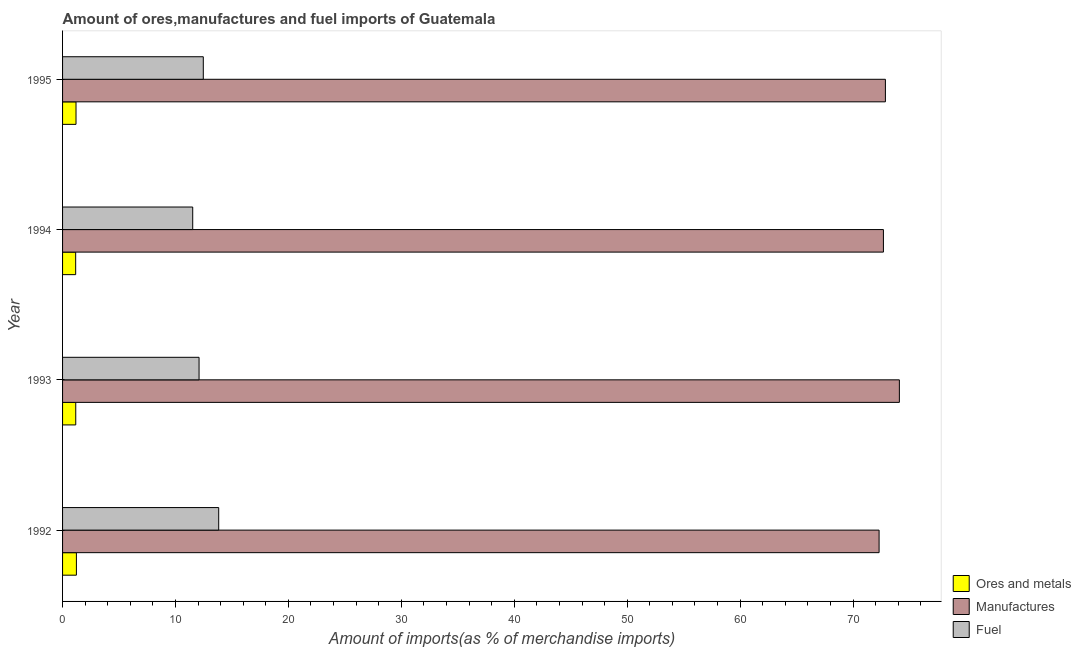How many different coloured bars are there?
Your answer should be compact. 3. How many groups of bars are there?
Provide a short and direct response. 4. Are the number of bars per tick equal to the number of legend labels?
Your response must be concise. Yes. How many bars are there on the 2nd tick from the top?
Make the answer very short. 3. What is the label of the 4th group of bars from the top?
Offer a very short reply. 1992. What is the percentage of manufactures imports in 1995?
Offer a very short reply. 72.87. Across all years, what is the maximum percentage of fuel imports?
Make the answer very short. 13.83. Across all years, what is the minimum percentage of ores and metals imports?
Provide a succinct answer. 1.16. In which year was the percentage of fuel imports minimum?
Offer a terse response. 1994. What is the total percentage of manufactures imports in the graph?
Your response must be concise. 291.98. What is the difference between the percentage of fuel imports in 1992 and that in 1993?
Your answer should be very brief. 1.74. What is the difference between the percentage of ores and metals imports in 1995 and the percentage of manufactures imports in 1993?
Make the answer very short. -72.92. What is the average percentage of fuel imports per year?
Make the answer very short. 12.48. In the year 1994, what is the difference between the percentage of ores and metals imports and percentage of fuel imports?
Give a very brief answer. -10.37. In how many years, is the percentage of manufactures imports greater than 68 %?
Provide a succinct answer. 4. What is the difference between the highest and the second highest percentage of manufactures imports?
Offer a very short reply. 1.24. What is the difference between the highest and the lowest percentage of ores and metals imports?
Offer a terse response. 0.06. In how many years, is the percentage of ores and metals imports greater than the average percentage of ores and metals imports taken over all years?
Keep it short and to the point. 2. Is the sum of the percentage of ores and metals imports in 1992 and 1993 greater than the maximum percentage of fuel imports across all years?
Give a very brief answer. No. What does the 3rd bar from the top in 1993 represents?
Your answer should be compact. Ores and metals. What does the 1st bar from the bottom in 1993 represents?
Give a very brief answer. Ores and metals. How many bars are there?
Offer a terse response. 12. How many years are there in the graph?
Give a very brief answer. 4. What is the difference between two consecutive major ticks on the X-axis?
Your answer should be very brief. 10. Are the values on the major ticks of X-axis written in scientific E-notation?
Provide a succinct answer. No. Does the graph contain grids?
Your answer should be compact. No. How many legend labels are there?
Your response must be concise. 3. How are the legend labels stacked?
Give a very brief answer. Vertical. What is the title of the graph?
Your answer should be compact. Amount of ores,manufactures and fuel imports of Guatemala. Does "Unpaid family workers" appear as one of the legend labels in the graph?
Provide a succinct answer. No. What is the label or title of the X-axis?
Offer a terse response. Amount of imports(as % of merchandise imports). What is the label or title of the Y-axis?
Keep it short and to the point. Year. What is the Amount of imports(as % of merchandise imports) of Ores and metals in 1992?
Keep it short and to the point. 1.23. What is the Amount of imports(as % of merchandise imports) in Manufactures in 1992?
Offer a terse response. 72.31. What is the Amount of imports(as % of merchandise imports) of Fuel in 1992?
Make the answer very short. 13.83. What is the Amount of imports(as % of merchandise imports) of Ores and metals in 1993?
Offer a terse response. 1.17. What is the Amount of imports(as % of merchandise imports) of Manufactures in 1993?
Offer a terse response. 74.11. What is the Amount of imports(as % of merchandise imports) of Fuel in 1993?
Offer a terse response. 12.09. What is the Amount of imports(as % of merchandise imports) in Ores and metals in 1994?
Ensure brevity in your answer.  1.16. What is the Amount of imports(as % of merchandise imports) in Manufactures in 1994?
Provide a succinct answer. 72.69. What is the Amount of imports(as % of merchandise imports) of Fuel in 1994?
Your answer should be very brief. 11.53. What is the Amount of imports(as % of merchandise imports) of Ores and metals in 1995?
Your answer should be compact. 1.19. What is the Amount of imports(as % of merchandise imports) in Manufactures in 1995?
Ensure brevity in your answer.  72.87. What is the Amount of imports(as % of merchandise imports) of Fuel in 1995?
Your answer should be compact. 12.46. Across all years, what is the maximum Amount of imports(as % of merchandise imports) of Ores and metals?
Your answer should be very brief. 1.23. Across all years, what is the maximum Amount of imports(as % of merchandise imports) of Manufactures?
Your response must be concise. 74.11. Across all years, what is the maximum Amount of imports(as % of merchandise imports) of Fuel?
Your response must be concise. 13.83. Across all years, what is the minimum Amount of imports(as % of merchandise imports) in Ores and metals?
Your answer should be very brief. 1.16. Across all years, what is the minimum Amount of imports(as % of merchandise imports) of Manufactures?
Your response must be concise. 72.31. Across all years, what is the minimum Amount of imports(as % of merchandise imports) in Fuel?
Provide a succinct answer. 11.53. What is the total Amount of imports(as % of merchandise imports) of Ores and metals in the graph?
Your answer should be compact. 4.74. What is the total Amount of imports(as % of merchandise imports) in Manufactures in the graph?
Offer a very short reply. 291.98. What is the total Amount of imports(as % of merchandise imports) of Fuel in the graph?
Provide a short and direct response. 49.9. What is the difference between the Amount of imports(as % of merchandise imports) in Ores and metals in 1992 and that in 1993?
Make the answer very short. 0.06. What is the difference between the Amount of imports(as % of merchandise imports) in Manufactures in 1992 and that in 1993?
Offer a terse response. -1.8. What is the difference between the Amount of imports(as % of merchandise imports) of Fuel in 1992 and that in 1993?
Offer a terse response. 1.74. What is the difference between the Amount of imports(as % of merchandise imports) of Ores and metals in 1992 and that in 1994?
Give a very brief answer. 0.06. What is the difference between the Amount of imports(as % of merchandise imports) in Manufactures in 1992 and that in 1994?
Your response must be concise. -0.38. What is the difference between the Amount of imports(as % of merchandise imports) in Fuel in 1992 and that in 1994?
Your answer should be compact. 2.3. What is the difference between the Amount of imports(as % of merchandise imports) in Ores and metals in 1992 and that in 1995?
Provide a short and direct response. 0.03. What is the difference between the Amount of imports(as % of merchandise imports) of Manufactures in 1992 and that in 1995?
Offer a very short reply. -0.56. What is the difference between the Amount of imports(as % of merchandise imports) in Fuel in 1992 and that in 1995?
Keep it short and to the point. 1.37. What is the difference between the Amount of imports(as % of merchandise imports) in Ores and metals in 1993 and that in 1994?
Ensure brevity in your answer.  0.01. What is the difference between the Amount of imports(as % of merchandise imports) of Manufactures in 1993 and that in 1994?
Ensure brevity in your answer.  1.41. What is the difference between the Amount of imports(as % of merchandise imports) in Fuel in 1993 and that in 1994?
Provide a short and direct response. 0.56. What is the difference between the Amount of imports(as % of merchandise imports) of Ores and metals in 1993 and that in 1995?
Your answer should be very brief. -0.02. What is the difference between the Amount of imports(as % of merchandise imports) in Manufactures in 1993 and that in 1995?
Offer a very short reply. 1.24. What is the difference between the Amount of imports(as % of merchandise imports) of Fuel in 1993 and that in 1995?
Offer a terse response. -0.37. What is the difference between the Amount of imports(as % of merchandise imports) in Ores and metals in 1994 and that in 1995?
Make the answer very short. -0.03. What is the difference between the Amount of imports(as % of merchandise imports) of Manufactures in 1994 and that in 1995?
Offer a very short reply. -0.18. What is the difference between the Amount of imports(as % of merchandise imports) in Fuel in 1994 and that in 1995?
Offer a very short reply. -0.94. What is the difference between the Amount of imports(as % of merchandise imports) of Ores and metals in 1992 and the Amount of imports(as % of merchandise imports) of Manufactures in 1993?
Offer a terse response. -72.88. What is the difference between the Amount of imports(as % of merchandise imports) in Ores and metals in 1992 and the Amount of imports(as % of merchandise imports) in Fuel in 1993?
Your answer should be very brief. -10.86. What is the difference between the Amount of imports(as % of merchandise imports) of Manufactures in 1992 and the Amount of imports(as % of merchandise imports) of Fuel in 1993?
Provide a short and direct response. 60.22. What is the difference between the Amount of imports(as % of merchandise imports) of Ores and metals in 1992 and the Amount of imports(as % of merchandise imports) of Manufactures in 1994?
Your response must be concise. -71.47. What is the difference between the Amount of imports(as % of merchandise imports) of Ores and metals in 1992 and the Amount of imports(as % of merchandise imports) of Fuel in 1994?
Give a very brief answer. -10.3. What is the difference between the Amount of imports(as % of merchandise imports) of Manufactures in 1992 and the Amount of imports(as % of merchandise imports) of Fuel in 1994?
Your answer should be very brief. 60.78. What is the difference between the Amount of imports(as % of merchandise imports) in Ores and metals in 1992 and the Amount of imports(as % of merchandise imports) in Manufactures in 1995?
Give a very brief answer. -71.64. What is the difference between the Amount of imports(as % of merchandise imports) in Ores and metals in 1992 and the Amount of imports(as % of merchandise imports) in Fuel in 1995?
Give a very brief answer. -11.24. What is the difference between the Amount of imports(as % of merchandise imports) in Manufactures in 1992 and the Amount of imports(as % of merchandise imports) in Fuel in 1995?
Give a very brief answer. 59.85. What is the difference between the Amount of imports(as % of merchandise imports) in Ores and metals in 1993 and the Amount of imports(as % of merchandise imports) in Manufactures in 1994?
Your answer should be compact. -71.53. What is the difference between the Amount of imports(as % of merchandise imports) in Ores and metals in 1993 and the Amount of imports(as % of merchandise imports) in Fuel in 1994?
Your response must be concise. -10.36. What is the difference between the Amount of imports(as % of merchandise imports) in Manufactures in 1993 and the Amount of imports(as % of merchandise imports) in Fuel in 1994?
Provide a succinct answer. 62.58. What is the difference between the Amount of imports(as % of merchandise imports) in Ores and metals in 1993 and the Amount of imports(as % of merchandise imports) in Manufactures in 1995?
Your response must be concise. -71.7. What is the difference between the Amount of imports(as % of merchandise imports) of Ores and metals in 1993 and the Amount of imports(as % of merchandise imports) of Fuel in 1995?
Ensure brevity in your answer.  -11.29. What is the difference between the Amount of imports(as % of merchandise imports) of Manufactures in 1993 and the Amount of imports(as % of merchandise imports) of Fuel in 1995?
Provide a succinct answer. 61.64. What is the difference between the Amount of imports(as % of merchandise imports) of Ores and metals in 1994 and the Amount of imports(as % of merchandise imports) of Manufactures in 1995?
Ensure brevity in your answer.  -71.71. What is the difference between the Amount of imports(as % of merchandise imports) in Ores and metals in 1994 and the Amount of imports(as % of merchandise imports) in Fuel in 1995?
Provide a short and direct response. -11.3. What is the difference between the Amount of imports(as % of merchandise imports) of Manufactures in 1994 and the Amount of imports(as % of merchandise imports) of Fuel in 1995?
Ensure brevity in your answer.  60.23. What is the average Amount of imports(as % of merchandise imports) in Ores and metals per year?
Ensure brevity in your answer.  1.19. What is the average Amount of imports(as % of merchandise imports) of Manufactures per year?
Your answer should be very brief. 73. What is the average Amount of imports(as % of merchandise imports) of Fuel per year?
Your response must be concise. 12.48. In the year 1992, what is the difference between the Amount of imports(as % of merchandise imports) in Ores and metals and Amount of imports(as % of merchandise imports) in Manufactures?
Offer a very short reply. -71.09. In the year 1992, what is the difference between the Amount of imports(as % of merchandise imports) in Ores and metals and Amount of imports(as % of merchandise imports) in Fuel?
Keep it short and to the point. -12.6. In the year 1992, what is the difference between the Amount of imports(as % of merchandise imports) of Manufactures and Amount of imports(as % of merchandise imports) of Fuel?
Your answer should be very brief. 58.48. In the year 1993, what is the difference between the Amount of imports(as % of merchandise imports) in Ores and metals and Amount of imports(as % of merchandise imports) in Manufactures?
Your answer should be compact. -72.94. In the year 1993, what is the difference between the Amount of imports(as % of merchandise imports) of Ores and metals and Amount of imports(as % of merchandise imports) of Fuel?
Ensure brevity in your answer.  -10.92. In the year 1993, what is the difference between the Amount of imports(as % of merchandise imports) in Manufactures and Amount of imports(as % of merchandise imports) in Fuel?
Keep it short and to the point. 62.02. In the year 1994, what is the difference between the Amount of imports(as % of merchandise imports) of Ores and metals and Amount of imports(as % of merchandise imports) of Manufactures?
Provide a succinct answer. -71.53. In the year 1994, what is the difference between the Amount of imports(as % of merchandise imports) of Ores and metals and Amount of imports(as % of merchandise imports) of Fuel?
Your answer should be very brief. -10.36. In the year 1994, what is the difference between the Amount of imports(as % of merchandise imports) of Manufactures and Amount of imports(as % of merchandise imports) of Fuel?
Provide a succinct answer. 61.17. In the year 1995, what is the difference between the Amount of imports(as % of merchandise imports) of Ores and metals and Amount of imports(as % of merchandise imports) of Manufactures?
Provide a succinct answer. -71.68. In the year 1995, what is the difference between the Amount of imports(as % of merchandise imports) of Ores and metals and Amount of imports(as % of merchandise imports) of Fuel?
Your response must be concise. -11.27. In the year 1995, what is the difference between the Amount of imports(as % of merchandise imports) in Manufactures and Amount of imports(as % of merchandise imports) in Fuel?
Make the answer very short. 60.41. What is the ratio of the Amount of imports(as % of merchandise imports) in Ores and metals in 1992 to that in 1993?
Offer a terse response. 1.05. What is the ratio of the Amount of imports(as % of merchandise imports) of Manufactures in 1992 to that in 1993?
Ensure brevity in your answer.  0.98. What is the ratio of the Amount of imports(as % of merchandise imports) of Fuel in 1992 to that in 1993?
Provide a succinct answer. 1.14. What is the ratio of the Amount of imports(as % of merchandise imports) of Ores and metals in 1992 to that in 1994?
Your response must be concise. 1.06. What is the ratio of the Amount of imports(as % of merchandise imports) in Fuel in 1992 to that in 1994?
Keep it short and to the point. 1.2. What is the ratio of the Amount of imports(as % of merchandise imports) in Ores and metals in 1992 to that in 1995?
Keep it short and to the point. 1.03. What is the ratio of the Amount of imports(as % of merchandise imports) of Fuel in 1992 to that in 1995?
Offer a terse response. 1.11. What is the ratio of the Amount of imports(as % of merchandise imports) of Ores and metals in 1993 to that in 1994?
Offer a very short reply. 1.01. What is the ratio of the Amount of imports(as % of merchandise imports) of Manufactures in 1993 to that in 1994?
Your answer should be compact. 1.02. What is the ratio of the Amount of imports(as % of merchandise imports) of Fuel in 1993 to that in 1994?
Offer a very short reply. 1.05. What is the ratio of the Amount of imports(as % of merchandise imports) in Ores and metals in 1993 to that in 1995?
Offer a very short reply. 0.98. What is the ratio of the Amount of imports(as % of merchandise imports) in Ores and metals in 1994 to that in 1995?
Keep it short and to the point. 0.97. What is the ratio of the Amount of imports(as % of merchandise imports) in Manufactures in 1994 to that in 1995?
Your answer should be very brief. 1. What is the ratio of the Amount of imports(as % of merchandise imports) in Fuel in 1994 to that in 1995?
Your answer should be very brief. 0.92. What is the difference between the highest and the second highest Amount of imports(as % of merchandise imports) of Ores and metals?
Provide a short and direct response. 0.03. What is the difference between the highest and the second highest Amount of imports(as % of merchandise imports) of Manufactures?
Provide a short and direct response. 1.24. What is the difference between the highest and the second highest Amount of imports(as % of merchandise imports) of Fuel?
Provide a short and direct response. 1.37. What is the difference between the highest and the lowest Amount of imports(as % of merchandise imports) of Ores and metals?
Give a very brief answer. 0.06. What is the difference between the highest and the lowest Amount of imports(as % of merchandise imports) in Manufactures?
Your answer should be very brief. 1.8. What is the difference between the highest and the lowest Amount of imports(as % of merchandise imports) in Fuel?
Your answer should be compact. 2.3. 